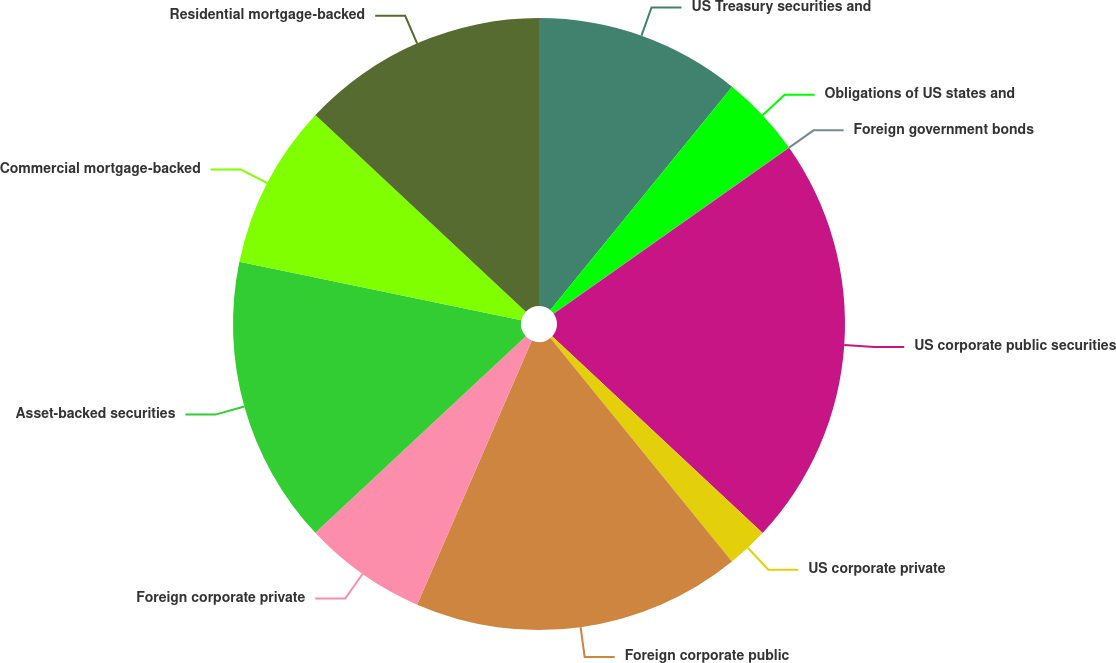Convert chart to OTSL. <chart><loc_0><loc_0><loc_500><loc_500><pie_chart><fcel>US Treasury securities and<fcel>Obligations of US states and<fcel>Foreign government bonds<fcel>US corporate public securities<fcel>US corporate private<fcel>Foreign corporate public<fcel>Foreign corporate private<fcel>Asset-backed securities<fcel>Commercial mortgage-backed<fcel>Residential mortgage-backed<nl><fcel>10.87%<fcel>4.35%<fcel>0.01%<fcel>21.73%<fcel>2.18%<fcel>17.38%<fcel>6.53%<fcel>15.21%<fcel>8.7%<fcel>13.04%<nl></chart> 